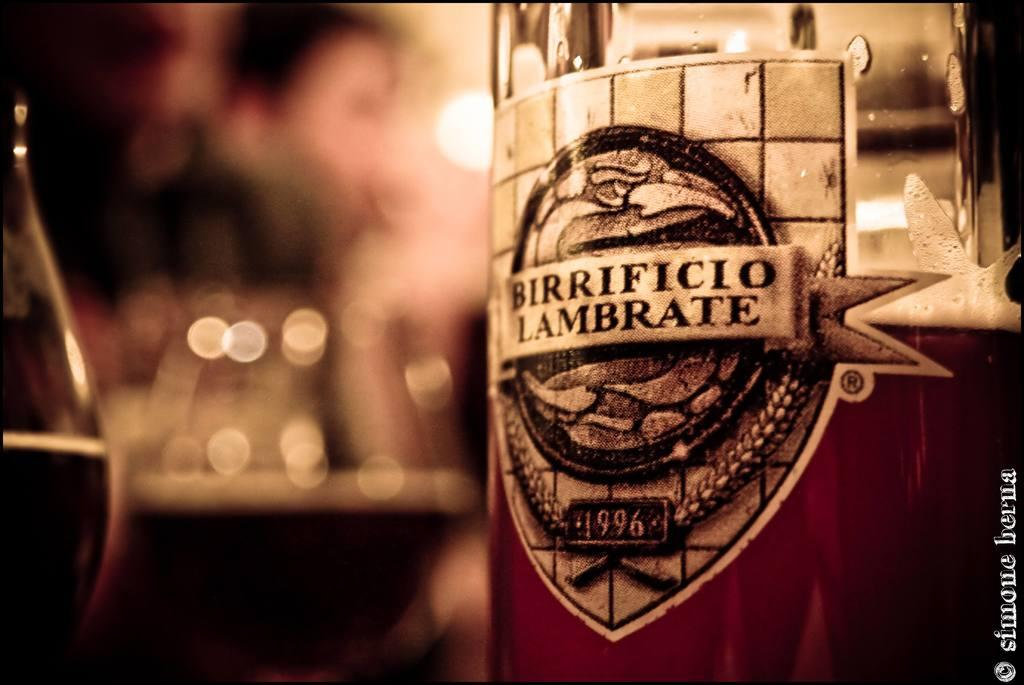<image>
Write a terse but informative summary of the picture. A bottle of Birrificio Lambrate that was made in 1996. 